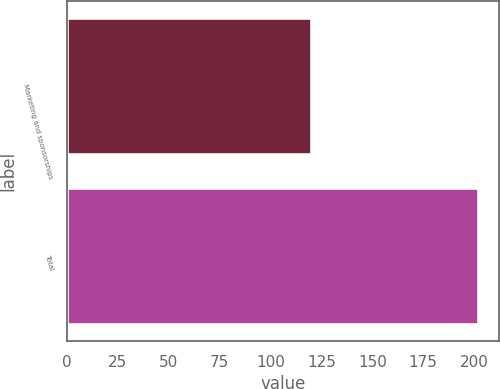Convert chart to OTSL. <chart><loc_0><loc_0><loc_500><loc_500><bar_chart><fcel>Marketing and sponsorships<fcel>Total<nl><fcel>120<fcel>202<nl></chart> 